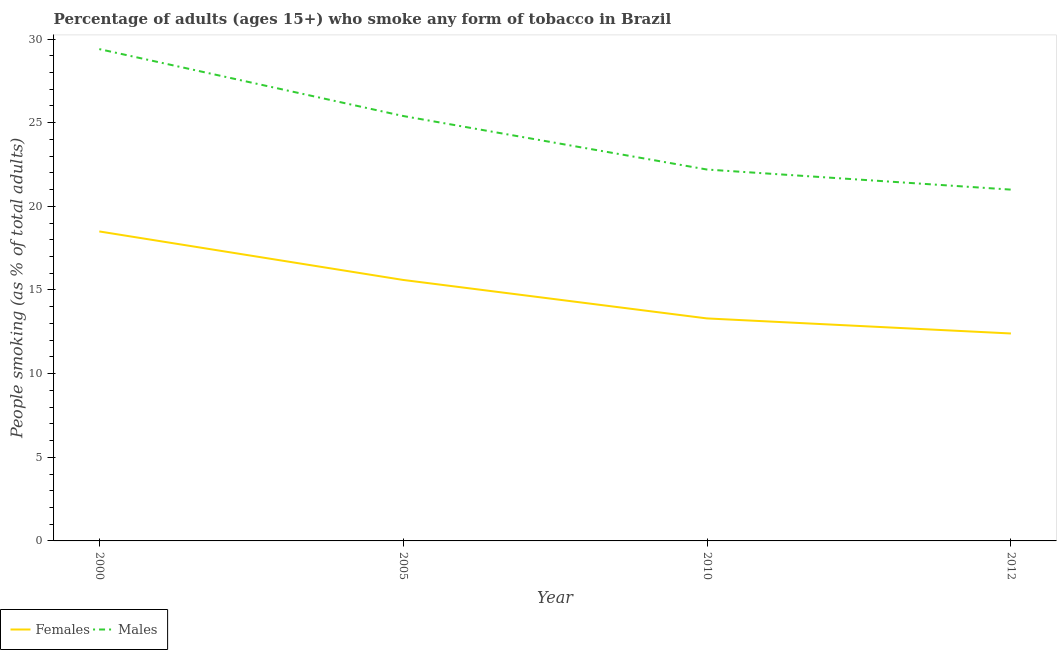What is the percentage of females who smoke in 2000?
Your response must be concise. 18.5. Across all years, what is the minimum percentage of females who smoke?
Keep it short and to the point. 12.4. In which year was the percentage of females who smoke minimum?
Offer a very short reply. 2012. What is the total percentage of females who smoke in the graph?
Keep it short and to the point. 59.8. What is the difference between the percentage of females who smoke in 2005 and that in 2010?
Make the answer very short. 2.3. In the year 2005, what is the difference between the percentage of males who smoke and percentage of females who smoke?
Make the answer very short. 9.8. What is the ratio of the percentage of males who smoke in 2005 to that in 2010?
Your response must be concise. 1.14. Is the percentage of males who smoke in 2000 less than that in 2010?
Make the answer very short. No. What is the difference between the highest and the lowest percentage of males who smoke?
Keep it short and to the point. 8.4. In how many years, is the percentage of females who smoke greater than the average percentage of females who smoke taken over all years?
Provide a succinct answer. 2. Is the sum of the percentage of males who smoke in 2000 and 2010 greater than the maximum percentage of females who smoke across all years?
Your answer should be compact. Yes. Does the percentage of females who smoke monotonically increase over the years?
Your answer should be compact. No. How many lines are there?
Your answer should be very brief. 2. Are the values on the major ticks of Y-axis written in scientific E-notation?
Provide a short and direct response. No. Does the graph contain grids?
Offer a terse response. No. How many legend labels are there?
Your answer should be compact. 2. What is the title of the graph?
Your answer should be very brief. Percentage of adults (ages 15+) who smoke any form of tobacco in Brazil. What is the label or title of the Y-axis?
Keep it short and to the point. People smoking (as % of total adults). What is the People smoking (as % of total adults) in Females in 2000?
Your answer should be very brief. 18.5. What is the People smoking (as % of total adults) in Males in 2000?
Ensure brevity in your answer.  29.4. What is the People smoking (as % of total adults) in Males in 2005?
Ensure brevity in your answer.  25.4. What is the People smoking (as % of total adults) in Females in 2010?
Your answer should be very brief. 13.3. What is the People smoking (as % of total adults) in Males in 2010?
Give a very brief answer. 22.2. What is the People smoking (as % of total adults) of Females in 2012?
Keep it short and to the point. 12.4. Across all years, what is the maximum People smoking (as % of total adults) in Females?
Offer a terse response. 18.5. Across all years, what is the maximum People smoking (as % of total adults) in Males?
Offer a very short reply. 29.4. Across all years, what is the minimum People smoking (as % of total adults) of Females?
Ensure brevity in your answer.  12.4. Across all years, what is the minimum People smoking (as % of total adults) of Males?
Your answer should be very brief. 21. What is the total People smoking (as % of total adults) in Females in the graph?
Provide a succinct answer. 59.8. What is the total People smoking (as % of total adults) of Males in the graph?
Offer a very short reply. 98. What is the difference between the People smoking (as % of total adults) in Males in 2000 and that in 2005?
Your answer should be very brief. 4. What is the difference between the People smoking (as % of total adults) in Males in 2000 and that in 2010?
Give a very brief answer. 7.2. What is the difference between the People smoking (as % of total adults) in Males in 2000 and that in 2012?
Provide a short and direct response. 8.4. What is the difference between the People smoking (as % of total adults) in Males in 2005 and that in 2010?
Provide a short and direct response. 3.2. What is the difference between the People smoking (as % of total adults) of Females in 2005 and that in 2012?
Offer a terse response. 3.2. What is the difference between the People smoking (as % of total adults) of Males in 2010 and that in 2012?
Offer a terse response. 1.2. What is the difference between the People smoking (as % of total adults) of Females in 2000 and the People smoking (as % of total adults) of Males in 2010?
Ensure brevity in your answer.  -3.7. What is the difference between the People smoking (as % of total adults) of Females in 2005 and the People smoking (as % of total adults) of Males in 2010?
Provide a short and direct response. -6.6. What is the difference between the People smoking (as % of total adults) in Females in 2005 and the People smoking (as % of total adults) in Males in 2012?
Make the answer very short. -5.4. What is the average People smoking (as % of total adults) of Females per year?
Your response must be concise. 14.95. In the year 2000, what is the difference between the People smoking (as % of total adults) in Females and People smoking (as % of total adults) in Males?
Your answer should be very brief. -10.9. In the year 2005, what is the difference between the People smoking (as % of total adults) in Females and People smoking (as % of total adults) in Males?
Offer a terse response. -9.8. In the year 2012, what is the difference between the People smoking (as % of total adults) in Females and People smoking (as % of total adults) in Males?
Offer a terse response. -8.6. What is the ratio of the People smoking (as % of total adults) in Females in 2000 to that in 2005?
Provide a short and direct response. 1.19. What is the ratio of the People smoking (as % of total adults) of Males in 2000 to that in 2005?
Offer a terse response. 1.16. What is the ratio of the People smoking (as % of total adults) in Females in 2000 to that in 2010?
Give a very brief answer. 1.39. What is the ratio of the People smoking (as % of total adults) in Males in 2000 to that in 2010?
Keep it short and to the point. 1.32. What is the ratio of the People smoking (as % of total adults) of Females in 2000 to that in 2012?
Ensure brevity in your answer.  1.49. What is the ratio of the People smoking (as % of total adults) of Females in 2005 to that in 2010?
Keep it short and to the point. 1.17. What is the ratio of the People smoking (as % of total adults) of Males in 2005 to that in 2010?
Your response must be concise. 1.14. What is the ratio of the People smoking (as % of total adults) in Females in 2005 to that in 2012?
Your response must be concise. 1.26. What is the ratio of the People smoking (as % of total adults) of Males in 2005 to that in 2012?
Keep it short and to the point. 1.21. What is the ratio of the People smoking (as % of total adults) in Females in 2010 to that in 2012?
Make the answer very short. 1.07. What is the ratio of the People smoking (as % of total adults) in Males in 2010 to that in 2012?
Your response must be concise. 1.06. What is the difference between the highest and the second highest People smoking (as % of total adults) of Females?
Keep it short and to the point. 2.9. What is the difference between the highest and the second highest People smoking (as % of total adults) of Males?
Offer a terse response. 4. What is the difference between the highest and the lowest People smoking (as % of total adults) in Females?
Make the answer very short. 6.1. What is the difference between the highest and the lowest People smoking (as % of total adults) in Males?
Your response must be concise. 8.4. 